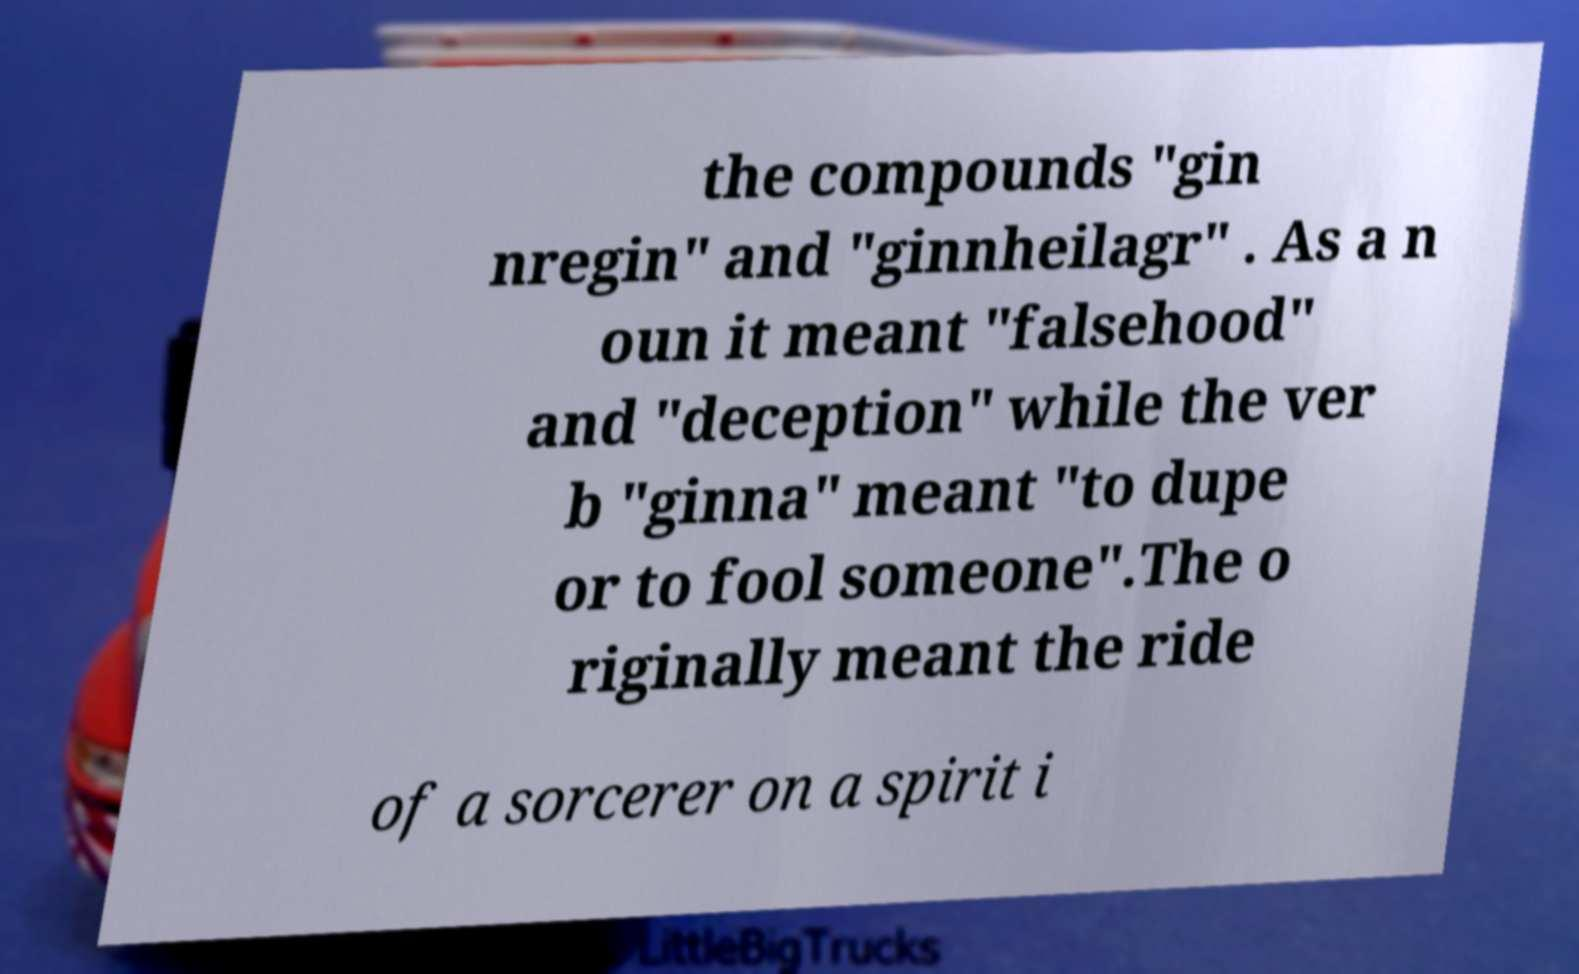There's text embedded in this image that I need extracted. Can you transcribe it verbatim? the compounds "gin nregin" and "ginnheilagr" . As a n oun it meant "falsehood" and "deception" while the ver b "ginna" meant "to dupe or to fool someone".The o riginally meant the ride of a sorcerer on a spirit i 